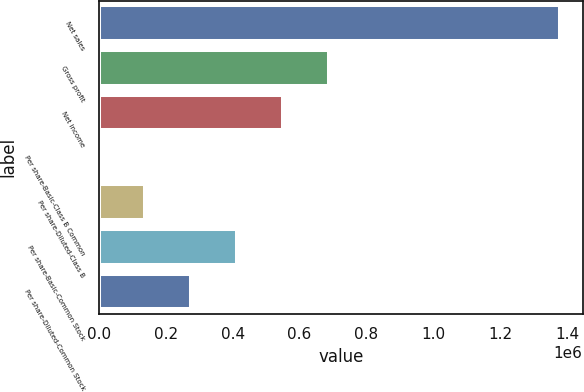Convert chart to OTSL. <chart><loc_0><loc_0><loc_500><loc_500><bar_chart><fcel>Net sales<fcel>Gross profit<fcel>Net income<fcel>Per share-Basic-Class B Common<fcel>Per share-Diluted-Class B<fcel>Per share-Basic-Common Stock<fcel>Per share-Diluted-Common Stock<nl><fcel>1.37738e+06<fcel>688690<fcel>550952<fcel>0.33<fcel>137738<fcel>413214<fcel>275476<nl></chart> 